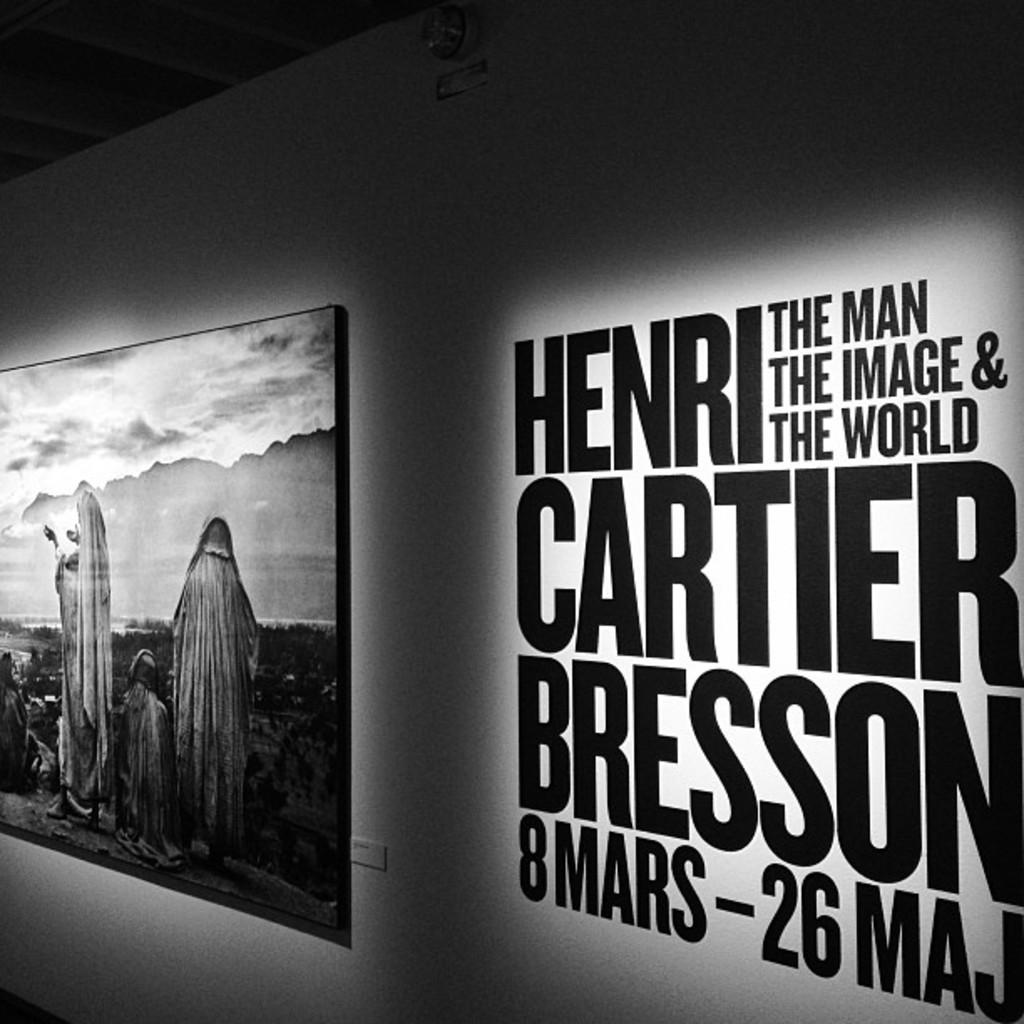What numbers are on the wall?
Your answer should be compact. 8 26. The displays are hendri?
Offer a very short reply. Unanswerable. 